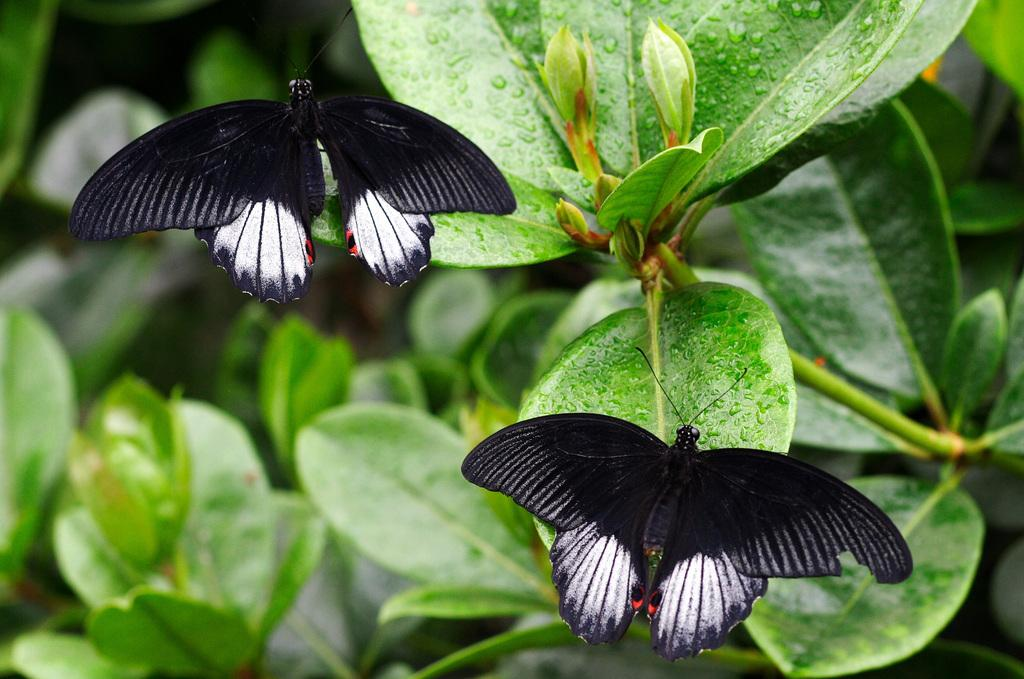What type of animals can be seen in the image? There are butterflies in the image. What type of plant material is present in the image? There are leaves and buds in the image. How many mice can be seen hiding among the leaves in the image? There are no mice present in the image; it features butterflies, leaves, and buds. Can you tell me the color of the yak in the image? There is no yak present in the image. 